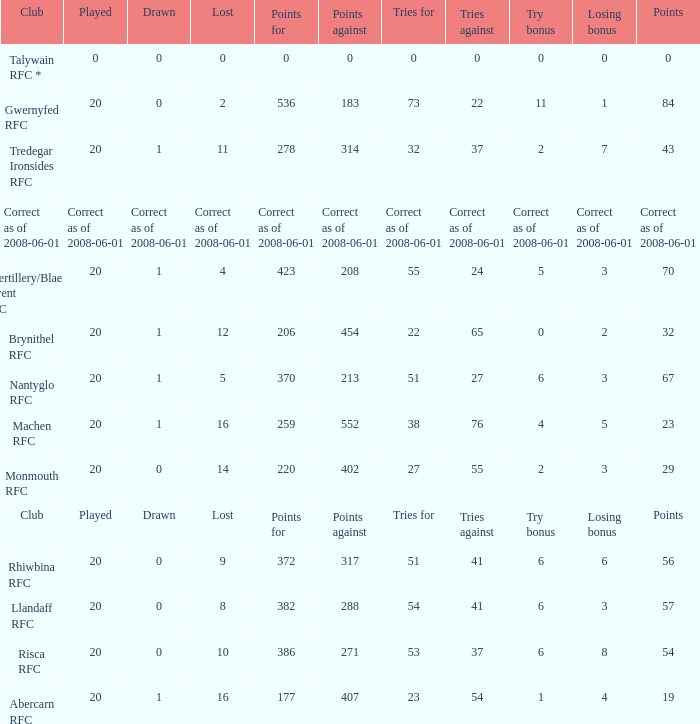If the points were 0, what was the losing bonus? 0.0. 